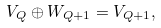<formula> <loc_0><loc_0><loc_500><loc_500>V _ { Q } \oplus W _ { Q + 1 } = V _ { Q + 1 } ,</formula> 